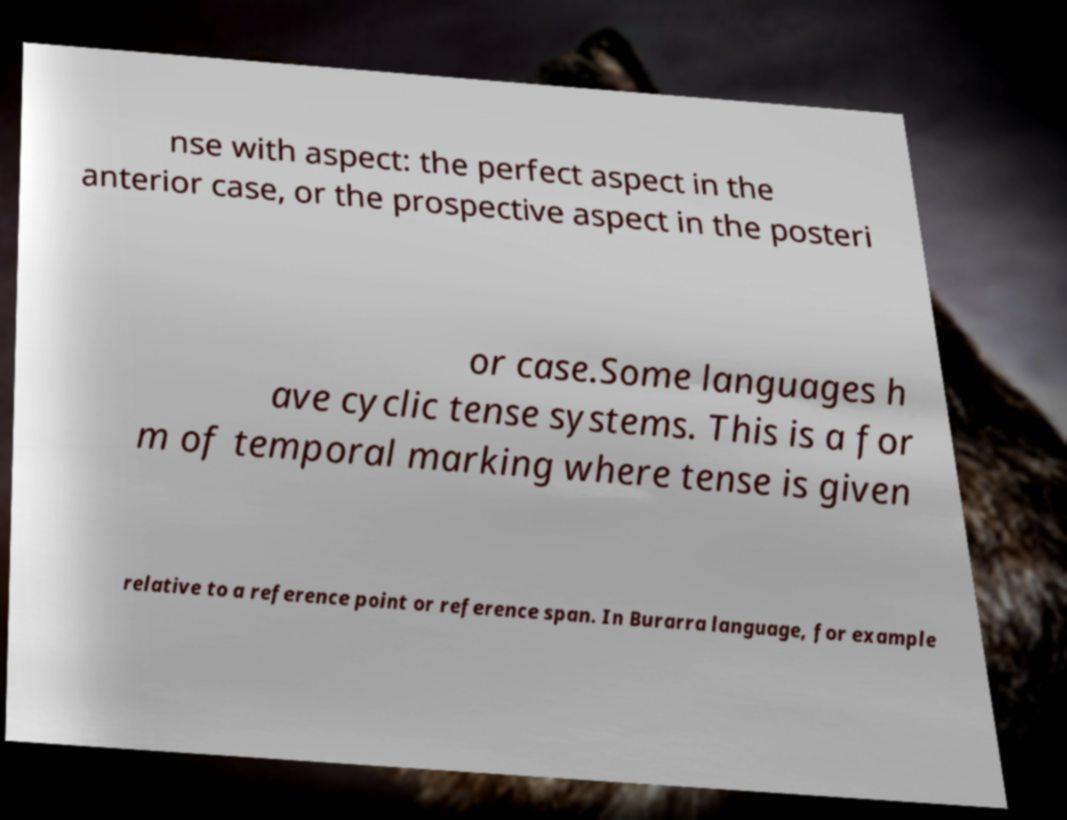Can you accurately transcribe the text from the provided image for me? nse with aspect: the perfect aspect in the anterior case, or the prospective aspect in the posteri or case.Some languages h ave cyclic tense systems. This is a for m of temporal marking where tense is given relative to a reference point or reference span. In Burarra language, for example 